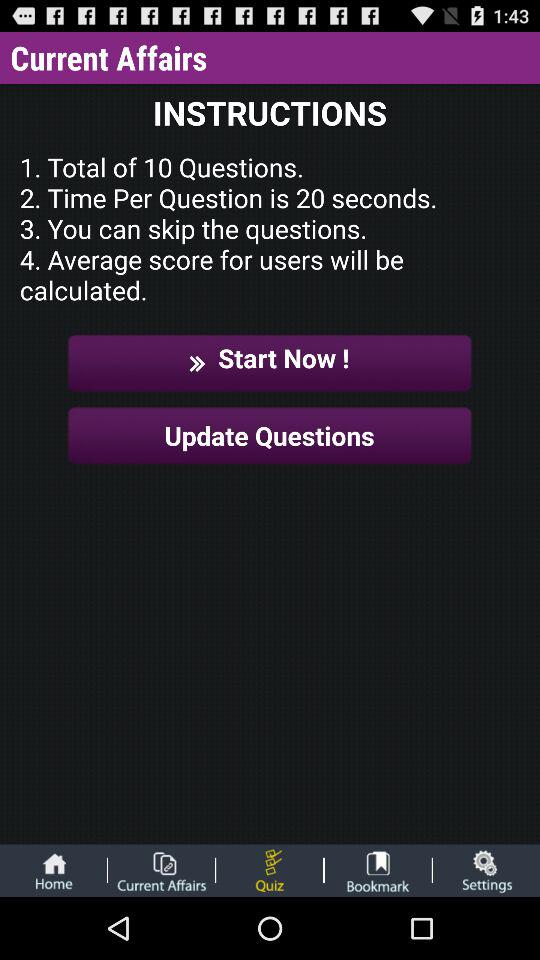How many instructions are there in total?
Answer the question using a single word or phrase. 4 